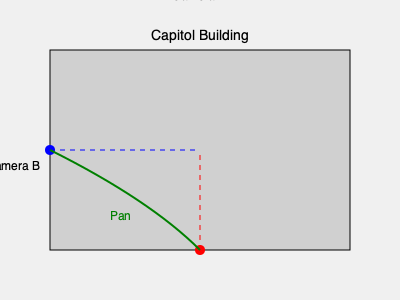In the iconic scene from "All the President's Men" (1976) where Woodward and Bernstein meet their informant at the Capitol, the camera employs a specific technique to heighten tension. Based on the diagram, which camera position and movement would best achieve this effect, and why? To answer this question, let's analyze the camera positions and movements shown in the diagram:

1. Camera A (red):
   - Positioned directly in front of the Capitol Building
   - Provides a straight-on, eye-level view
   - Limited movement potential

2. Camera B (blue):
   - Positioned to the side of the Capitol Building
   - Offers a more dynamic, angled perspective
   - Allows for interesting composition with the building as a backdrop

3. The green arrow indicates a panning movement from Camera A to Camera B

The most effective technique to heighten tension in this scene would be:

Step 1: Start with Camera A for an establishing shot of the Capitol Building.
Step 2: Slowly pan from Camera A to Camera B (following the green arrow).
Step 3: End on Camera B's position for the conversation between the characters.

This technique works because:
a) The initial frontal view establishes the iconic location.
b) The panning movement creates a sense of unease and anticipation.
c) The final angled view from Camera B adds visual interest and allows for better framing of the characters against the imposing backdrop of the Capitol.

This camera movement mirrors the tension and secrecy of the meeting, as the characters are metaphorically moving from the open, public space (Camera A) to a more secretive, shadowy encounter (Camera B).
Answer: Panning from Camera A to B, ending on B's angled view 